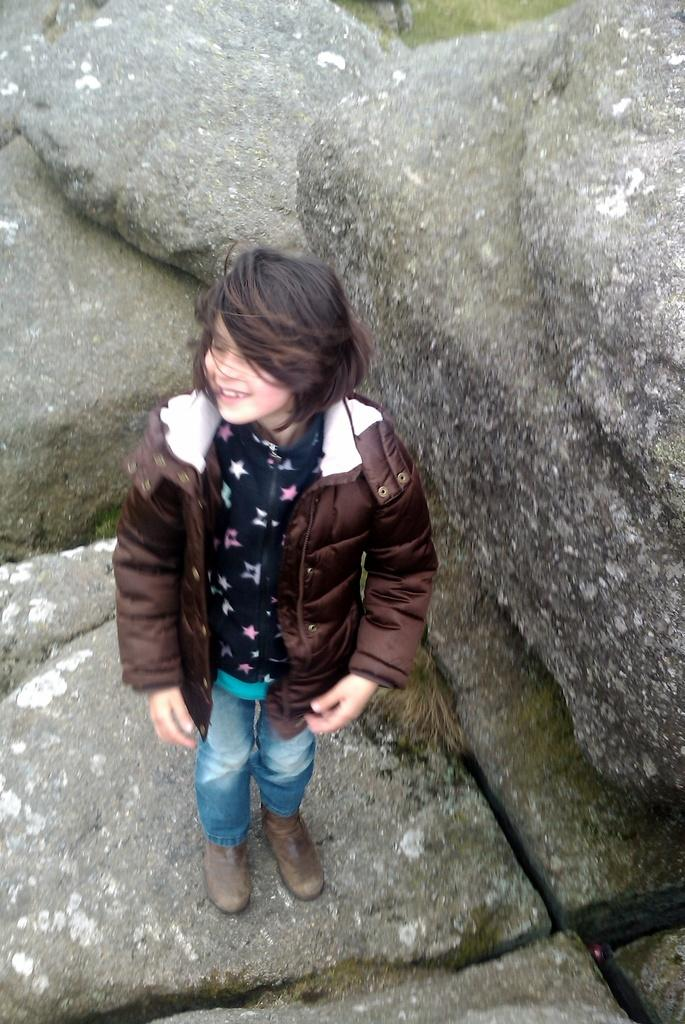What is the main subject of the image? There is a girl standing in the center of the image. What is the girl wearing? The girl is wearing a jacket. What can be seen in the background of the image? There are rocks in the background of the image. How many children are visible in the image? There is only one girl visible in the image, so there are no other children present. 